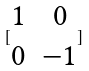<formula> <loc_0><loc_0><loc_500><loc_500>[ \begin{matrix} 1 & 0 \\ 0 & - 1 \end{matrix} ]</formula> 